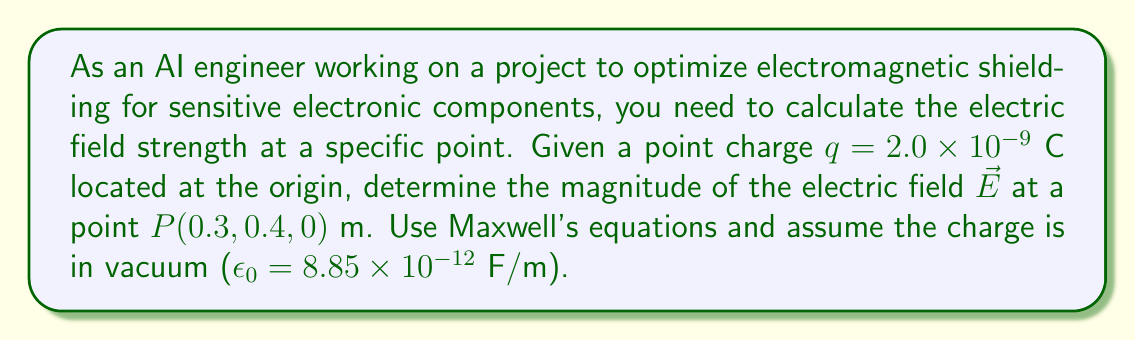Solve this math problem. To solve this problem, we'll use Maxwell's equation for the electric field due to a point charge:

$$\vec{E} = \frac{1}{4\pi\epsilon_0} \frac{q}{r^2} \hat{r}$$

Where:
- $\epsilon_0$ is the permittivity of free space
- $q$ is the charge
- $r$ is the distance from the charge to the point of interest
- $\hat{r}$ is the unit vector pointing from the charge to the point of interest

Steps:
1. Calculate the distance $r$ from the origin to point $P$:
   $$r = \sqrt{(0.3)^2 + (0.4)^2 + (0)^2} = \sqrt{0.09 + 0.16} = \sqrt{0.25} = 0.5 \text{ m}$$

2. Substitute the values into the equation:
   $$|\vec{E}| = \frac{1}{4\pi(8.85 \times 10^{-12})} \frac{2.0 \times 10^{-9}}{(0.5)^2}$$

3. Calculate the result:
   $$|\vec{E}| = \frac{2.0 \times 10^{-9}}{4\pi(8.85 \times 10^{-12})(0.25)}$$
   $$|\vec{E}| = \frac{2.0 \times 10^{-9}}{2.78 \times 10^{-12}}$$
   $$|\vec{E}| = 719.4 \text{ N/C}$$

The magnitude of the electric field at point $P$ is approximately 719.4 N/C.
Answer: 719.4 N/C 